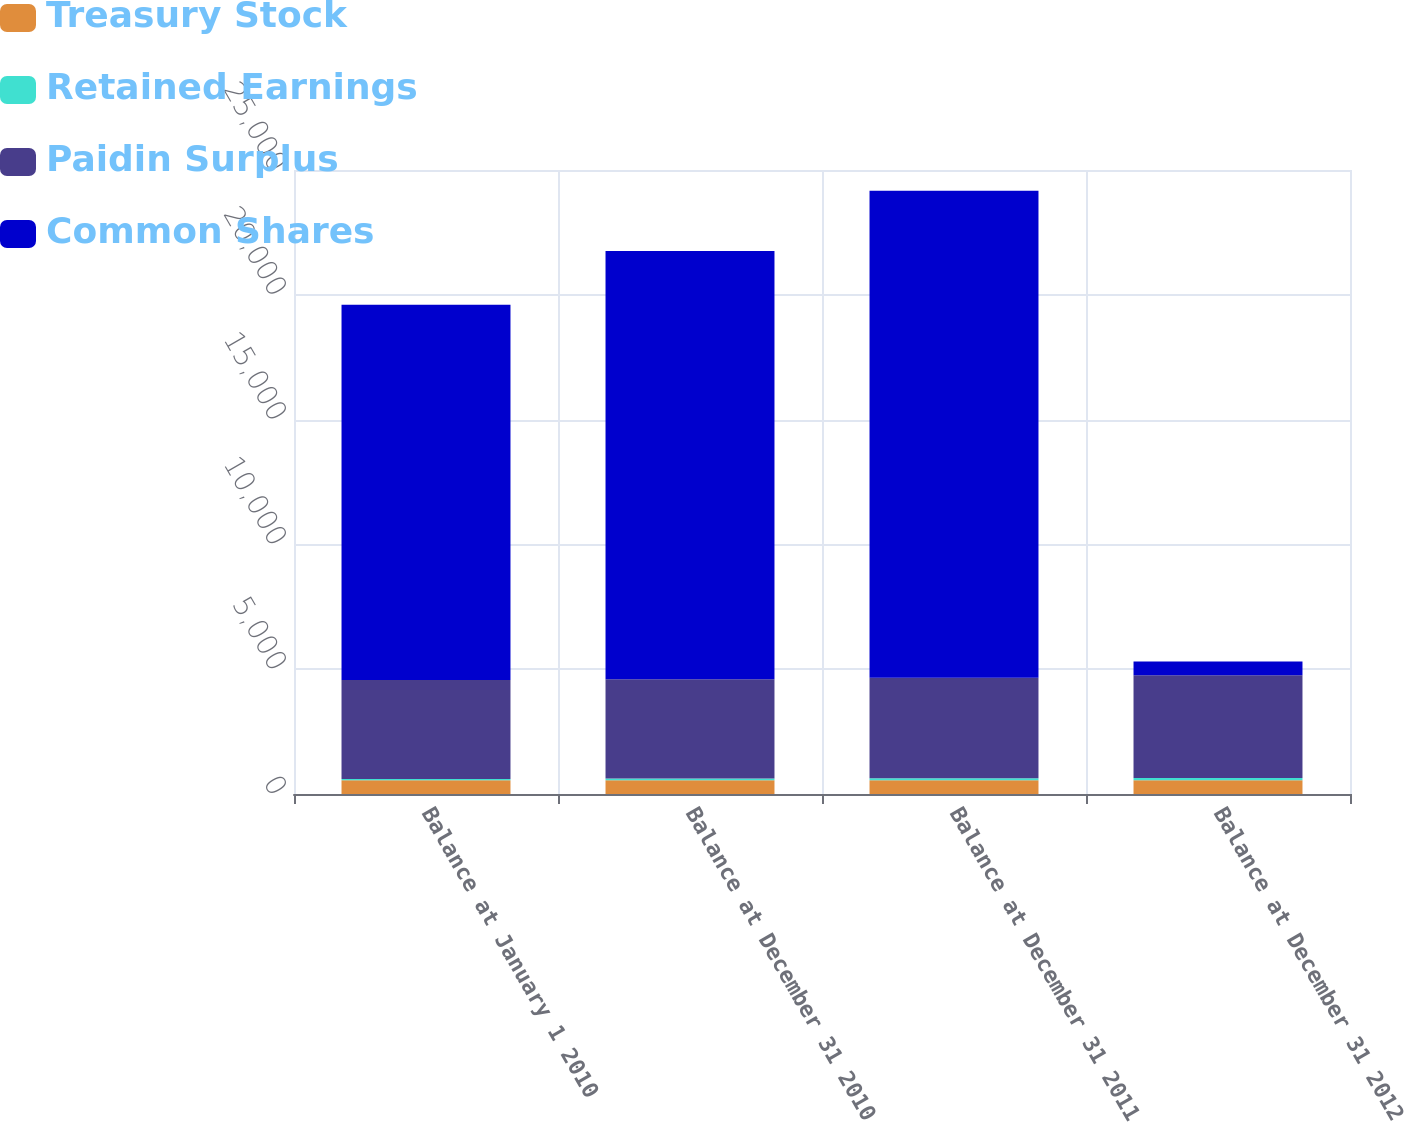Convert chart to OTSL. <chart><loc_0><loc_0><loc_500><loc_500><stacked_bar_chart><ecel><fcel>Balance at January 1 2010<fcel>Balance at December 31 2010<fcel>Balance at December 31 2011<fcel>Balance at December 31 2012<nl><fcel>Treasury Stock<fcel>553.5<fcel>553.9<fcel>554.3<fcel>554.6<nl><fcel>Retained Earnings<fcel>48.5<fcel>62.3<fcel>74.4<fcel>85.1<nl><fcel>Paidin Surplus<fcel>3968<fcel>3985<fcel>4031<fcel>4113<nl><fcel>Common Shares<fcel>15027<fcel>17154<fcel>19508<fcel>554.6<nl></chart> 